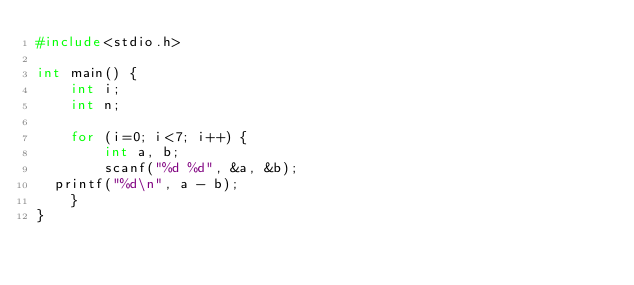Convert code to text. <code><loc_0><loc_0><loc_500><loc_500><_C++_>#include<stdio.h>

int main() {
    int i;
    int n;

    for (i=0; i<7; i++) {
        int a, b;
        scanf("%d %d", &a, &b);
	printf("%d\n", a - b);
    }
}</code> 